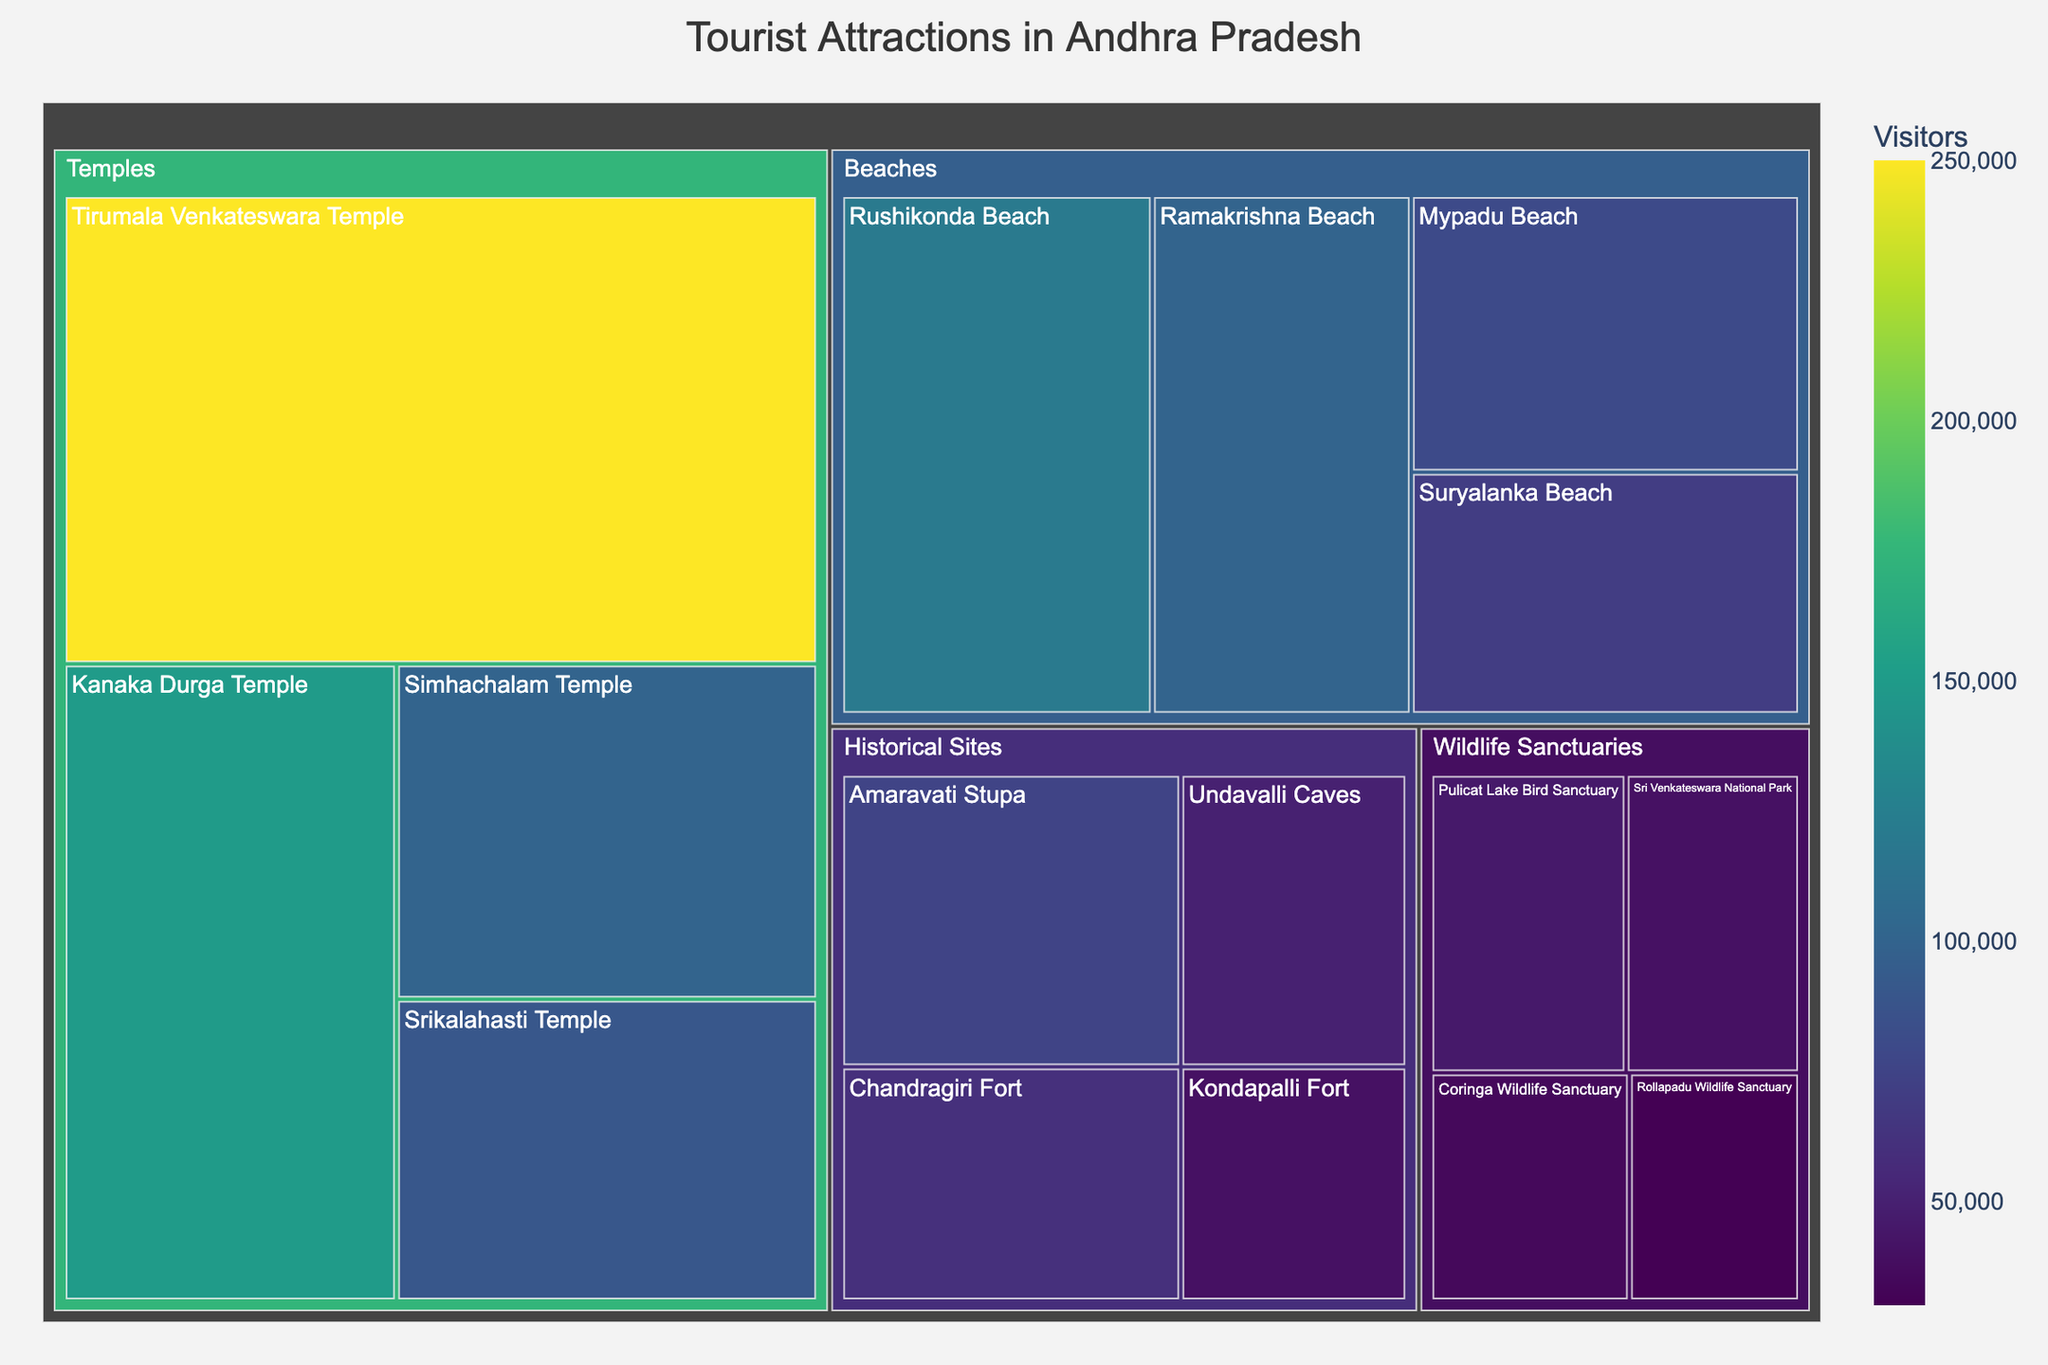Which type of tourist attraction has the highest number of visitors? By examining the treemap, we see that 'Temples' has the largest total area, indicating the highest sum of visitors across all attractions within this category.
Answer: Temples Which tourist attraction has the most visitors overall? Within the 'Temples' category, the 'Tirumala Venkateswara Temple' has the largest block, which means it has the most visitors.
Answer: Tirumala Venkateswara Temple Which category has the lowest number of total visitors? By comparing the areas of each category, 'Wildlife Sanctuaries' has the smallest total area, indicating it has the lowest sum of visitors.
Answer: Wildlife Sanctuaries How many visitors does Suryalanka Beach attract? Locate the 'Beaches' category, then find the 'Suryalanka Beach' and read the number of visitors from the block.
Answer: 70,000 What's the difference in the number of visitors between Rushikonda Beach and Ramakrishna Beach? Identify and find the visitor numbers for both beaches: Rushikonda Beach (120,000) and Ramakrishna Beach (100,000). Subtract visitors of Ramakrishna from Rushikonda.
Answer: 20,000 Which historical site has more visitors, Amaravati Stupa or Chandragiri Fort? Compare the areas (or visitor numbers) of both 'Amaravati Stupa' (75,000) and 'Chandragiri Fort' (60,000) within the 'Historical Sites' category.
Answer: Amaravati Stupa What is the total number of visitors for all Beach attractions combined? Sum up the number of visitors for all items under the 'Beaches' category: 120,000 + 100,000 + 80,000 + 70,000.
Answer: 370,000 Which temple has fewer visitors, Simhachalam Temple or Srikalahasti Temple? Compare the areas (or visitor numbers) of both 'Simhachalam Temple' (100,000) and 'Srikalahasti Temple' (90,000) within the 'Temples' category.
Answer: Srikalahasti Temple What's the average number of visitors to Wildlife Sanctuaries? Sum up the visitors for all wildlife sanctuaries and divide by the number of sanctuaries: (45,000 + 40,000 + 35,000 + 30,000) / 4.
Answer: 37,500 